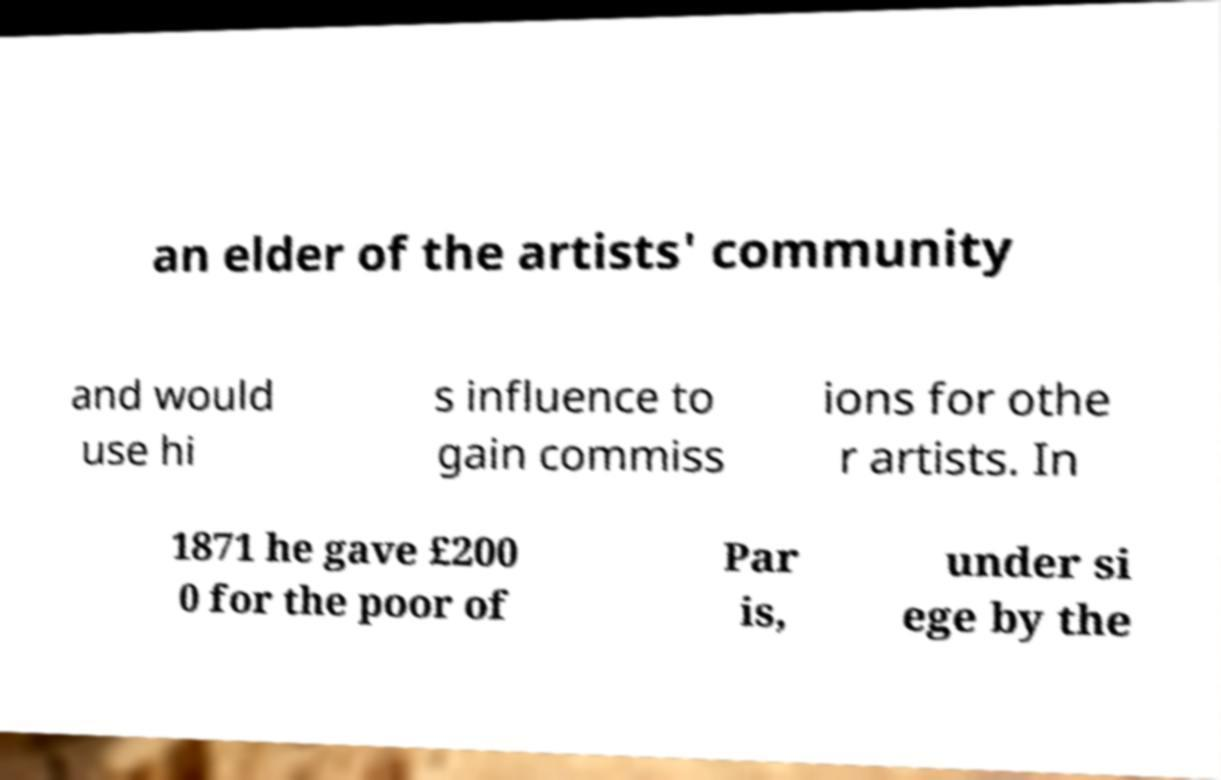Please identify and transcribe the text found in this image. an elder of the artists' community and would use hi s influence to gain commiss ions for othe r artists. In 1871 he gave £200 0 for the poor of Par is, under si ege by the 